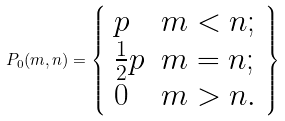<formula> <loc_0><loc_0><loc_500><loc_500>P _ { 0 } ( m , n ) = \left \{ \begin{array} { l l l } p & m < n ; \\ \frac { 1 } { 2 } p & m = n ; \\ 0 & m > n . \\ \end{array} \right \}</formula> 